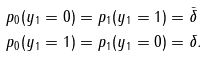Convert formula to latex. <formula><loc_0><loc_0><loc_500><loc_500>p _ { 0 } ( y _ { 1 } = 0 ) & = p _ { 1 } ( y _ { 1 } = 1 ) = \bar { \delta } \\ p _ { 0 } ( y _ { 1 } = 1 ) & = p _ { 1 } ( y _ { 1 } = 0 ) = \delta .</formula> 